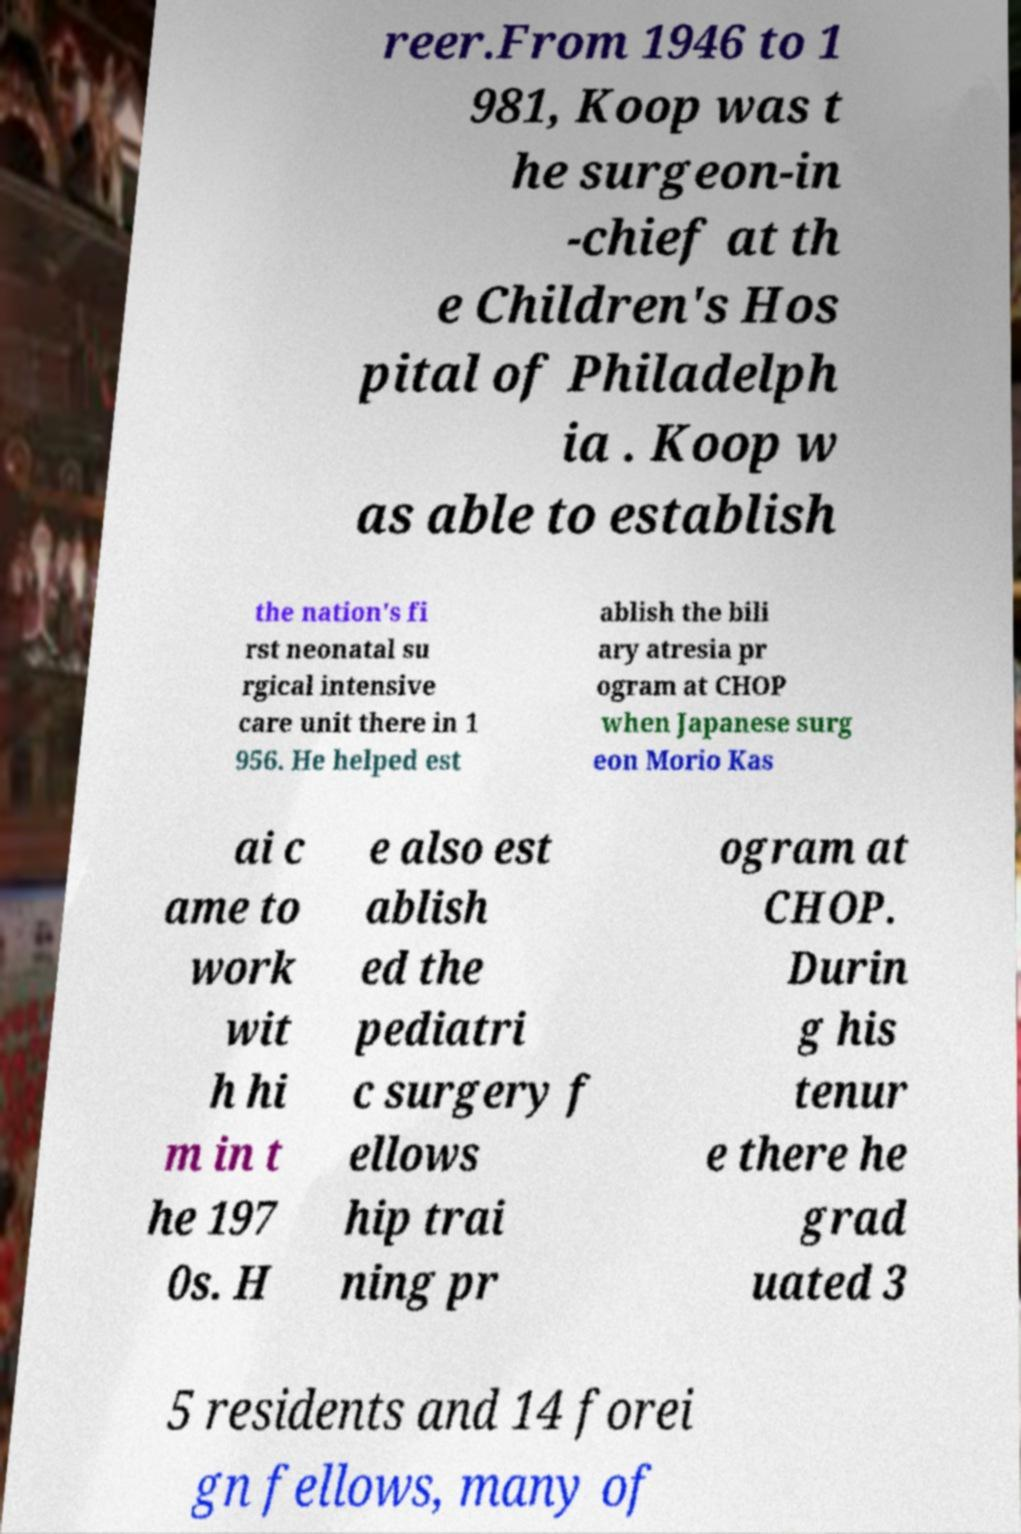For documentation purposes, I need the text within this image transcribed. Could you provide that? reer.From 1946 to 1 981, Koop was t he surgeon-in -chief at th e Children's Hos pital of Philadelph ia . Koop w as able to establish the nation's fi rst neonatal su rgical intensive care unit there in 1 956. He helped est ablish the bili ary atresia pr ogram at CHOP when Japanese surg eon Morio Kas ai c ame to work wit h hi m in t he 197 0s. H e also est ablish ed the pediatri c surgery f ellows hip trai ning pr ogram at CHOP. Durin g his tenur e there he grad uated 3 5 residents and 14 forei gn fellows, many of 